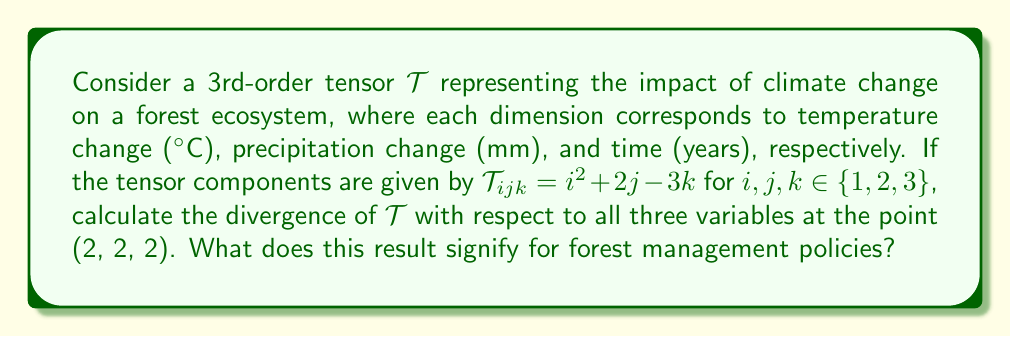Could you help me with this problem? 1) The divergence of a 3rd-order tensor $\mathcal{T}$ is given by:

   $$\text{div}(\mathcal{T}) = \frac{\partial \mathcal{T}_{ijk}}{\partial x_i} + \frac{\partial \mathcal{T}_{ijk}}{\partial x_j} + \frac{\partial \mathcal{T}_{ijk}}{\partial x_k}$$

2) We need to calculate each partial derivative:

   $\frac{\partial \mathcal{T}_{ijk}}{\partial x_i} = \frac{\partial}{\partial i}(i^2 + 2j - 3k) = 2i$
   
   $\frac{\partial \mathcal{T}_{ijk}}{\partial x_j} = \frac{\partial}{\partial j}(i^2 + 2j - 3k) = 2$
   
   $\frac{\partial \mathcal{T}_{ijk}}{\partial x_k} = \frac{\partial}{\partial k}(i^2 + 2j - 3k) = -3$

3) Evaluate at the point (2, 2, 2):

   $\frac{\partial \mathcal{T}_{ijk}}{\partial x_i}|_{(2,2,2)} = 2(2) = 4$
   
   $\frac{\partial \mathcal{T}_{ijk}}{\partial x_j}|_{(2,2,2)} = 2$
   
   $\frac{\partial \mathcal{T}_{ijk}}{\partial x_k}|_{(2,2,2)} = -3$

4) Sum the partial derivatives:

   $\text{div}(\mathcal{T})|_{(2,2,2)} = 4 + 2 + (-3) = 3$

5) Interpretation: The positive divergence (3) indicates a net outflow or increase in the impact of climate change on the forest ecosystem at the given point. This suggests that the combined effects of temperature and precipitation changes over time are amplifying, which may require more stringent forest management policies to mitigate the impact.
Answer: 3 (indicating increasing climate change impact, necessitating stricter forest management policies) 